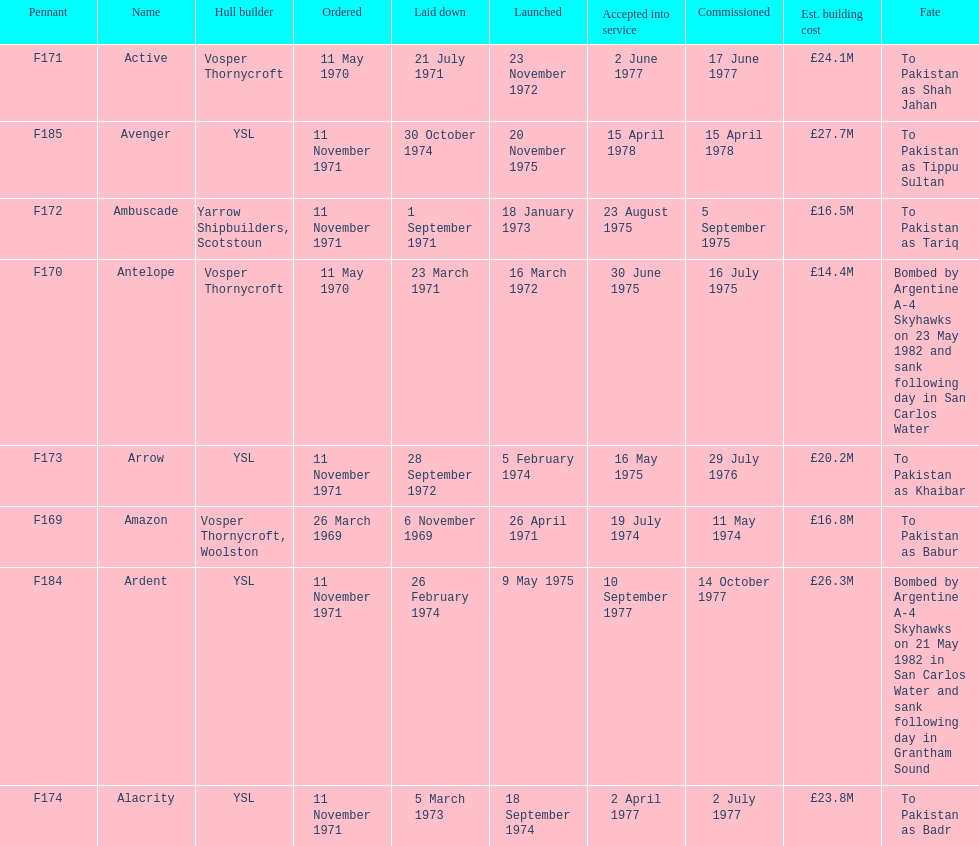Would you be able to parse every entry in this table? {'header': ['Pennant', 'Name', 'Hull builder', 'Ordered', 'Laid down', 'Launched', 'Accepted into service', 'Commissioned', 'Est. building cost', 'Fate'], 'rows': [['F171', 'Active', 'Vosper Thornycroft', '11 May 1970', '21 July 1971', '23 November 1972', '2 June 1977', '17 June 1977', '£24.1M', 'To Pakistan as Shah Jahan'], ['F185', 'Avenger', 'YSL', '11 November 1971', '30 October 1974', '20 November 1975', '15 April 1978', '15 April 1978', '£27.7M', 'To Pakistan as Tippu Sultan'], ['F172', 'Ambuscade', 'Yarrow Shipbuilders, Scotstoun', '11 November 1971', '1 September 1971', '18 January 1973', '23 August 1975', '5 September 1975', '£16.5M', 'To Pakistan as Tariq'], ['F170', 'Antelope', 'Vosper Thornycroft', '11 May 1970', '23 March 1971', '16 March 1972', '30 June 1975', '16 July 1975', '£14.4M', 'Bombed by Argentine A-4 Skyhawks on 23 May 1982 and sank following day in San Carlos Water'], ['F173', 'Arrow', 'YSL', '11 November 1971', '28 September 1972', '5 February 1974', '16 May 1975', '29 July 1976', '£20.2M', 'To Pakistan as Khaibar'], ['F169', 'Amazon', 'Vosper Thornycroft, Woolston', '26 March 1969', '6 November 1969', '26 April 1971', '19 July 1974', '11 May 1974', '£16.8M', 'To Pakistan as Babur'], ['F184', 'Ardent', 'YSL', '11 November 1971', '26 February 1974', '9 May 1975', '10 September 1977', '14 October 1977', '£26.3M', 'Bombed by Argentine A-4 Skyhawks on 21 May 1982 in San Carlos Water and sank following day in Grantham Sound'], ['F174', 'Alacrity', 'YSL', '11 November 1971', '5 March 1973', '18 September 1974', '2 April 1977', '2 July 1977', '£23.8M', 'To Pakistan as Badr']]} What is the name of the ship listed after ardent? Avenger. 